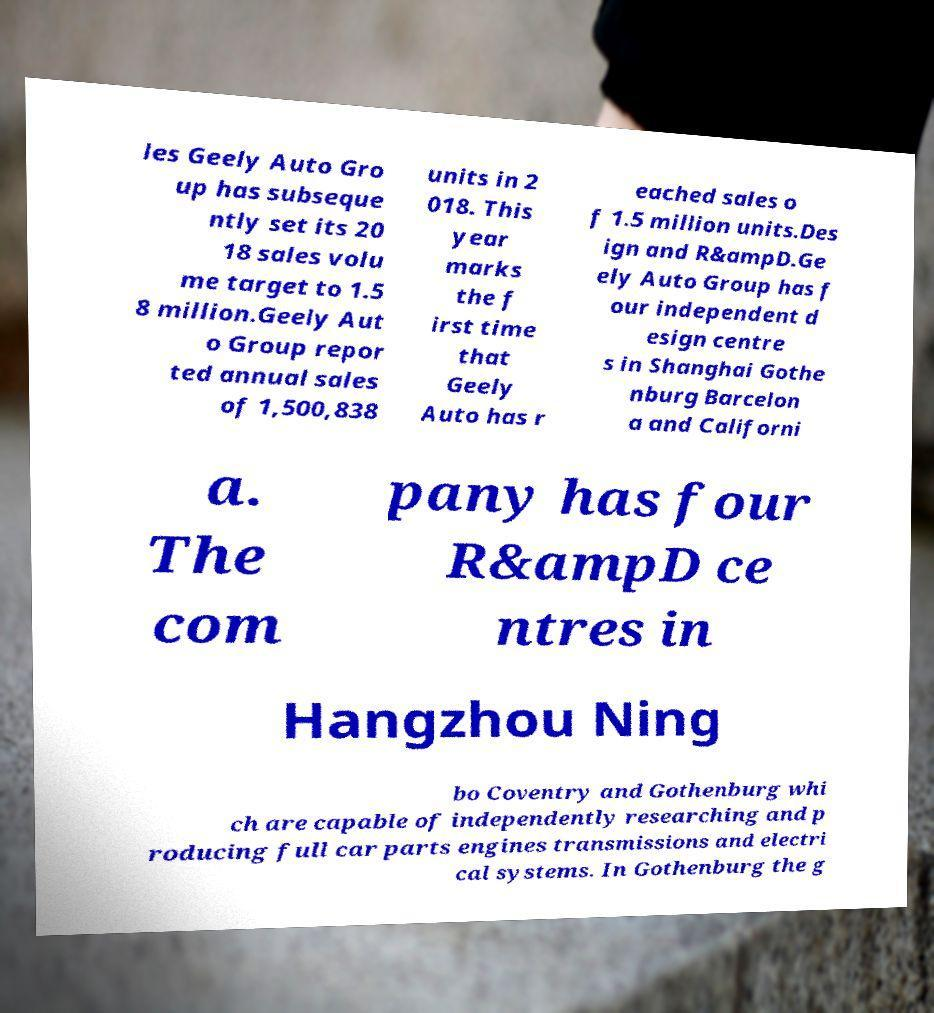For documentation purposes, I need the text within this image transcribed. Could you provide that? les Geely Auto Gro up has subseque ntly set its 20 18 sales volu me target to 1.5 8 million.Geely Aut o Group repor ted annual sales of 1,500,838 units in 2 018. This year marks the f irst time that Geely Auto has r eached sales o f 1.5 million units.Des ign and R&ampD.Ge ely Auto Group has f our independent d esign centre s in Shanghai Gothe nburg Barcelon a and Californi a. The com pany has four R&ampD ce ntres in Hangzhou Ning bo Coventry and Gothenburg whi ch are capable of independently researching and p roducing full car parts engines transmissions and electri cal systems. In Gothenburg the g 